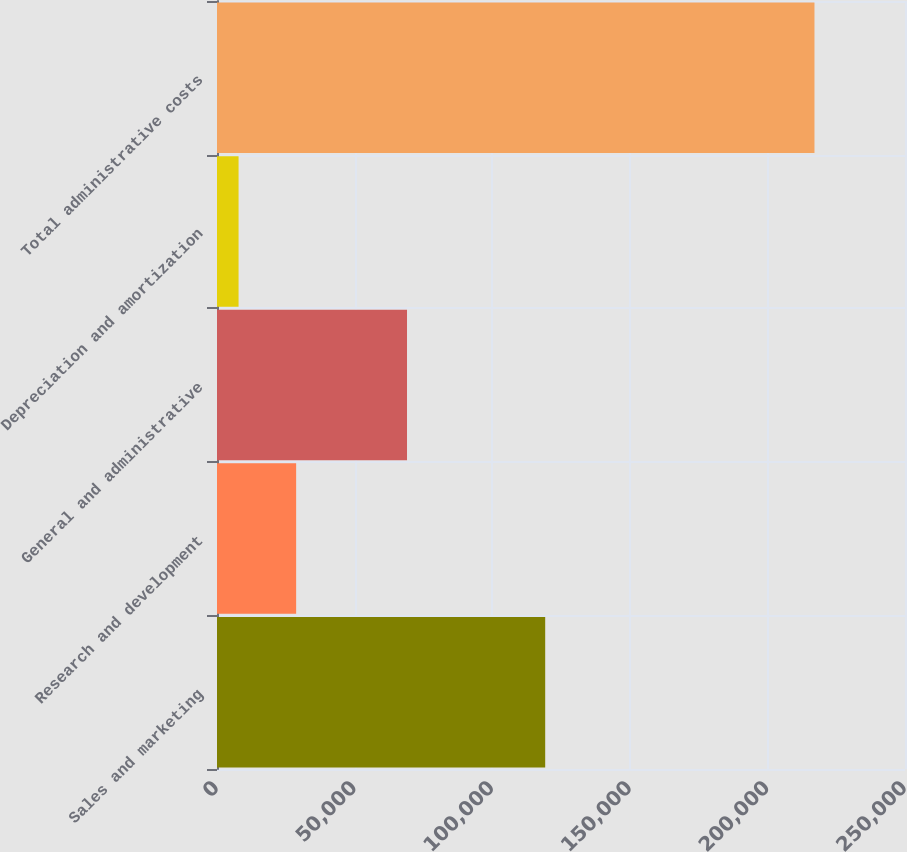<chart> <loc_0><loc_0><loc_500><loc_500><bar_chart><fcel>Sales and marketing<fcel>Research and development<fcel>General and administrative<fcel>Depreciation and amortization<fcel>Total administrative costs<nl><fcel>119258<fcel>28761<fcel>69046<fcel>7834<fcel>217104<nl></chart> 